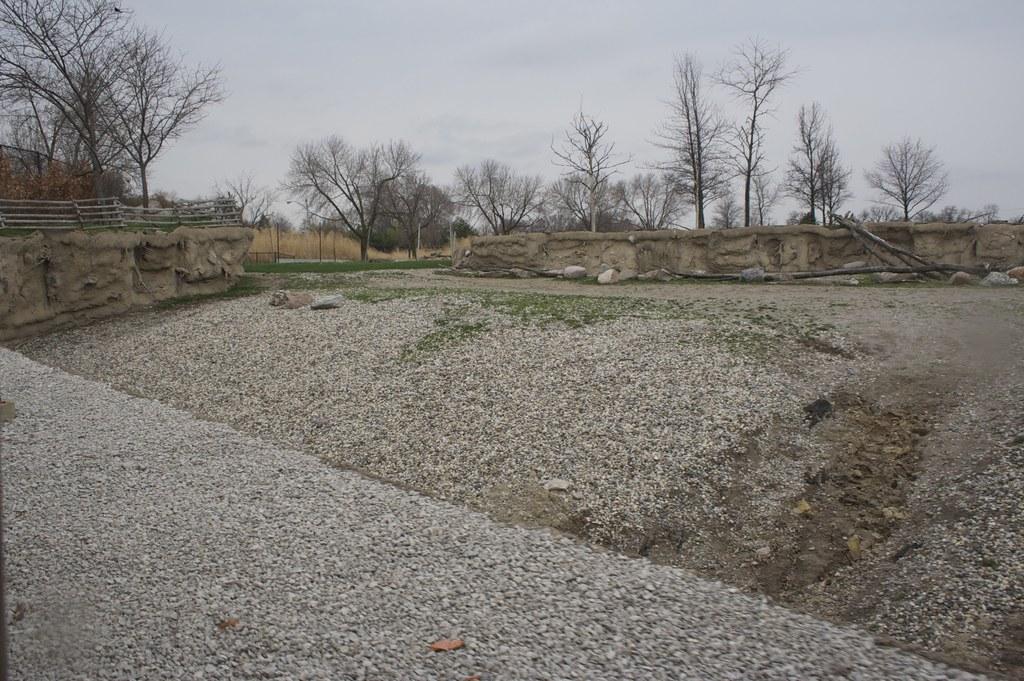Could you give a brief overview of what you see in this image? In this image I see the stones over here and I see the walls and I see number of trees and I see the fencing over here. In the background I see the sky. 